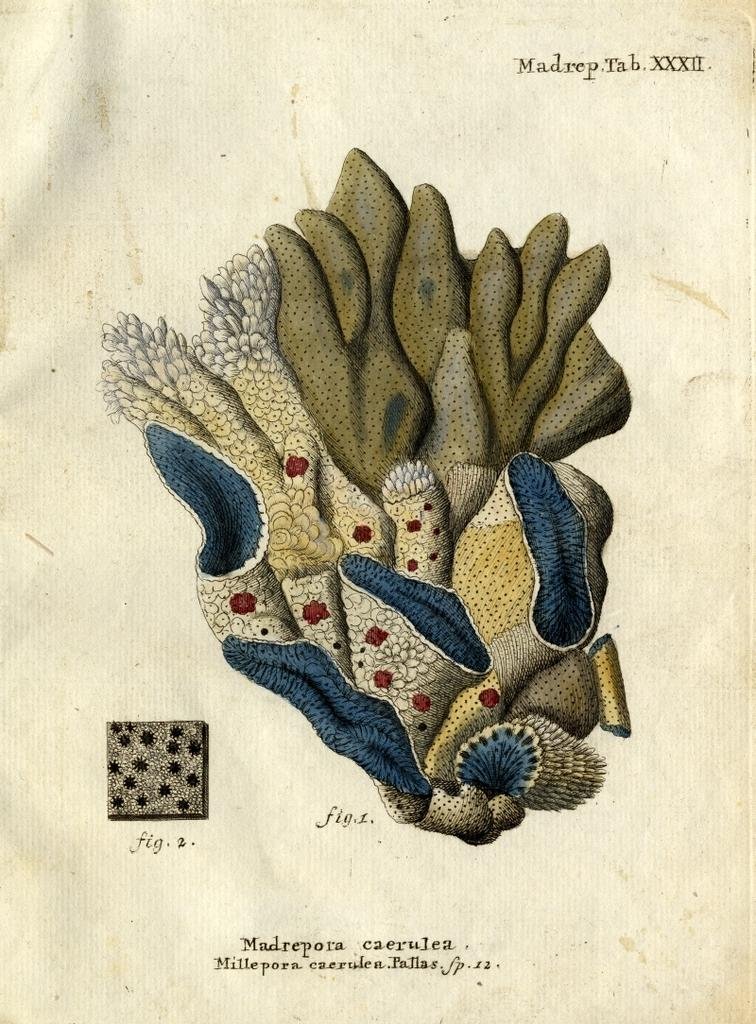What is the main subject in the image? There is an object in the image. Can you describe any additional details about the object? Unfortunately, there is not enough information provided to describe any additional details about the object. What is located at the bottom of the image? There is text on a paper at the bottom of the image. Can you provide any information about the content of the text? Unfortunately, there is not enough information provided to determine the content of the text. What type of transport is used by the person in the image? There is no person or transport present in the image. What hour of the day is depicted in the image? There is no indication of time or hour in the image. 